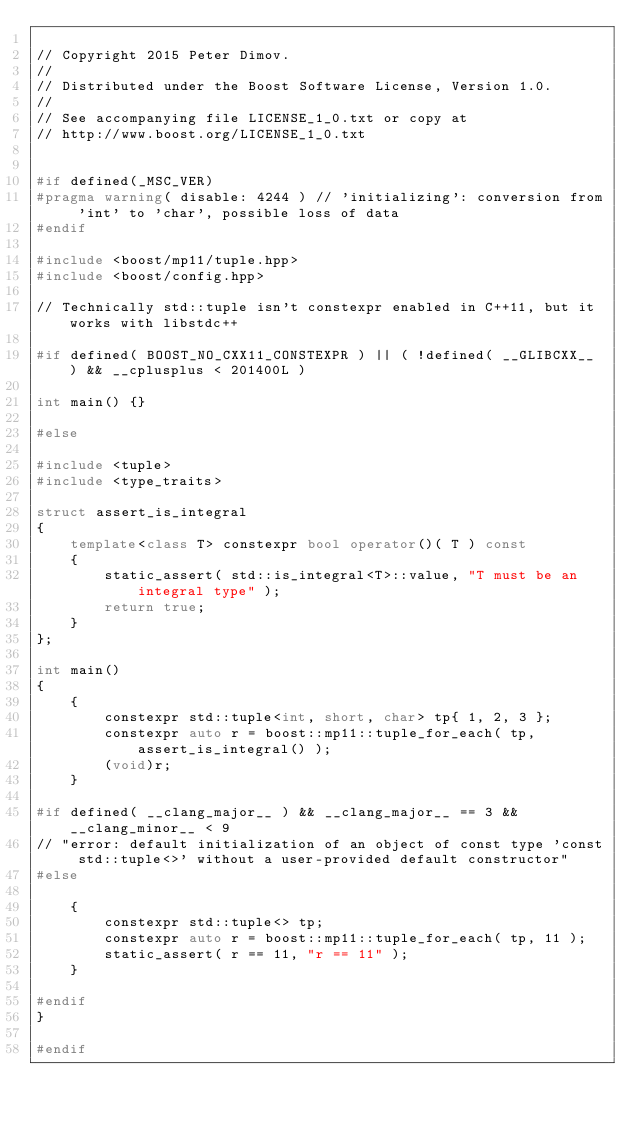<code> <loc_0><loc_0><loc_500><loc_500><_C++_>
// Copyright 2015 Peter Dimov.
//
// Distributed under the Boost Software License, Version 1.0.
//
// See accompanying file LICENSE_1_0.txt or copy at
// http://www.boost.org/LICENSE_1_0.txt


#if defined(_MSC_VER)
#pragma warning( disable: 4244 ) // 'initializing': conversion from 'int' to 'char', possible loss of data
#endif

#include <boost/mp11/tuple.hpp>
#include <boost/config.hpp>

// Technically std::tuple isn't constexpr enabled in C++11, but it works with libstdc++

#if defined( BOOST_NO_CXX11_CONSTEXPR ) || ( !defined( __GLIBCXX__ ) && __cplusplus < 201400L )

int main() {}

#else

#include <tuple>
#include <type_traits>

struct assert_is_integral
{
    template<class T> constexpr bool operator()( T ) const
    {
        static_assert( std::is_integral<T>::value, "T must be an integral type" );
        return true;
    }
};

int main()
{
    {
        constexpr std::tuple<int, short, char> tp{ 1, 2, 3 };
        constexpr auto r = boost::mp11::tuple_for_each( tp, assert_is_integral() );
        (void)r;
    }

#if defined( __clang_major__ ) && __clang_major__ == 3 && __clang_minor__ < 9
// "error: default initialization of an object of const type 'const std::tuple<>' without a user-provided default constructor"
#else

    {
        constexpr std::tuple<> tp;
        constexpr auto r = boost::mp11::tuple_for_each( tp, 11 );
        static_assert( r == 11, "r == 11" );
    }

#endif
}

#endif
</code> 